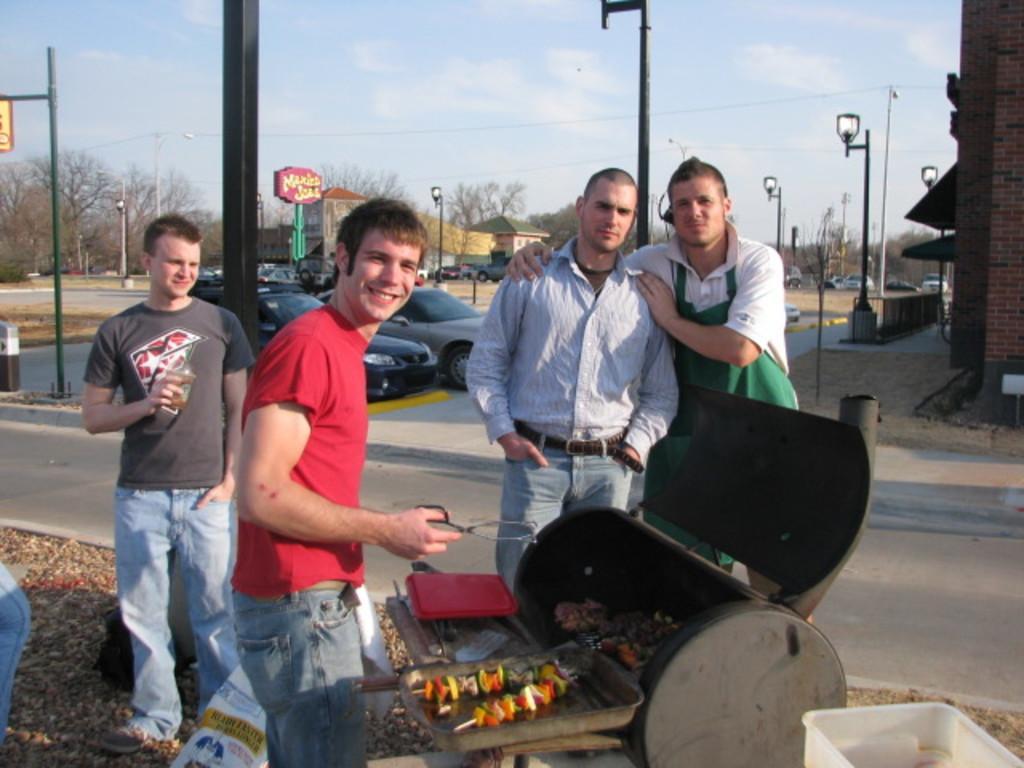Could you give a brief overview of what you see in this image? In this image I can see people are standing on the ground. Here I can see food item, girl and other objects on the ground. In the background I can see vehicles, trees, poles, buildings, wires and the sky. 